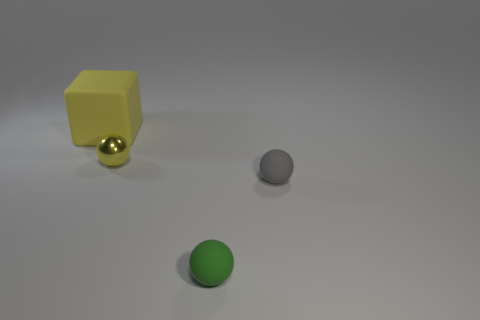Can you describe the shapes and colors present in the image? Certainly! In the image, there are three objects on a flat surface. From left to right, there's a yellow cube, a shiny golden sphere, and a matte grey sphere. The background seems to be uniformly lit with a soft white light. 